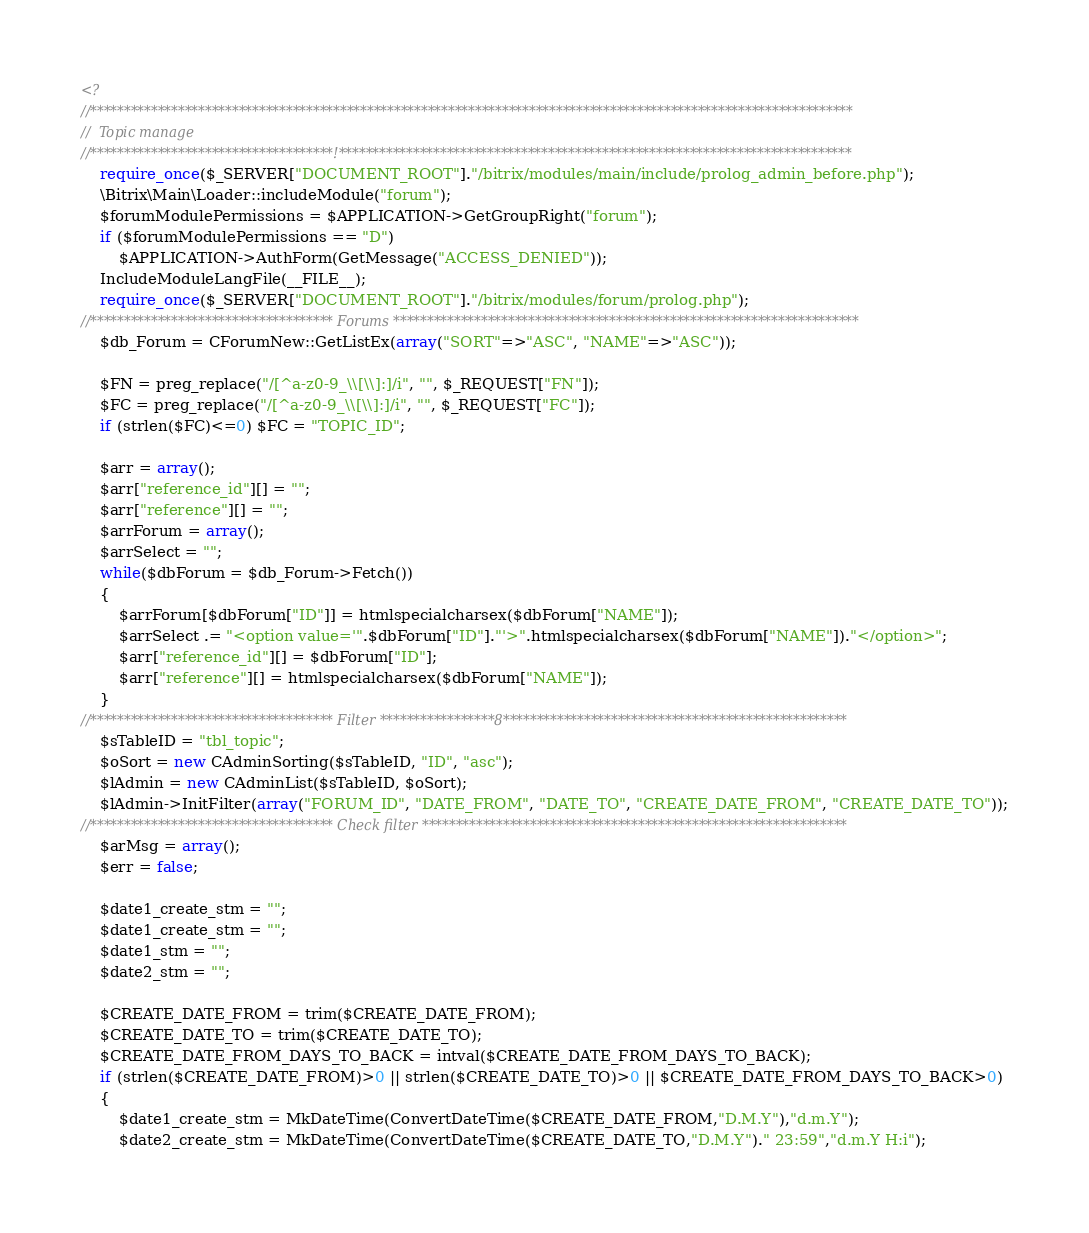Convert code to text. <code><loc_0><loc_0><loc_500><loc_500><_PHP_><?
//*****************************************************************************************************************
//	Topic manage
//************************************!****************************************************************************
	require_once($_SERVER["DOCUMENT_ROOT"]."/bitrix/modules/main/include/prolog_admin_before.php");
	\Bitrix\Main\Loader::includeModule("forum");
	$forumModulePermissions = $APPLICATION->GetGroupRight("forum");
	if ($forumModulePermissions == "D")
		$APPLICATION->AuthForm(GetMessage("ACCESS_DENIED"));
	IncludeModuleLangFile(__FILE__);
	require_once($_SERVER["DOCUMENT_ROOT"]."/bitrix/modules/forum/prolog.php");
//************************************ Forums *********************************************************************
	$db_Forum = CForumNew::GetListEx(array("SORT"=>"ASC", "NAME"=>"ASC"));

	$FN = preg_replace("/[^a-z0-9_\\[\\]:]/i", "", $_REQUEST["FN"]);
	$FC = preg_replace("/[^a-z0-9_\\[\\]:]/i", "", $_REQUEST["FC"]);
	if (strlen($FC)<=0) $FC = "TOPIC_ID";

	$arr = array();
	$arr["reference_id"][] = "";
	$arr["reference"][] = "";
	$arrForum = array();
	$arrSelect = "";
	while($dbForum = $db_Forum->Fetch())
	{
		$arrForum[$dbForum["ID"]] = htmlspecialcharsex($dbForum["NAME"]);
		$arrSelect .= "<option value='".$dbForum["ID"]."'>".htmlspecialcharsex($dbForum["NAME"])."</option>";
		$arr["reference_id"][] = $dbForum["ID"];
		$arr["reference"][] = htmlspecialcharsex($dbForum["NAME"]);
	}
//************************************ Filter *****************8***************************************************
	$sTableID = "tbl_topic";
	$oSort = new CAdminSorting($sTableID, "ID", "asc");
	$lAdmin = new CAdminList($sTableID, $oSort);
	$lAdmin->InitFilter(array("FORUM_ID", "DATE_FROM", "DATE_TO", "CREATE_DATE_FROM", "CREATE_DATE_TO"));
//************************************ Check filter ***************************************************************
	$arMsg = array();
	$err = false;

	$date1_create_stm = "";
	$date1_create_stm = "";
	$date1_stm = "";
	$date2_stm = "";

	$CREATE_DATE_FROM = trim($CREATE_DATE_FROM);
	$CREATE_DATE_TO = trim($CREATE_DATE_TO);
	$CREATE_DATE_FROM_DAYS_TO_BACK = intval($CREATE_DATE_FROM_DAYS_TO_BACK);
	if (strlen($CREATE_DATE_FROM)>0 || strlen($CREATE_DATE_TO)>0 || $CREATE_DATE_FROM_DAYS_TO_BACK>0)
	{
		$date1_create_stm = MkDateTime(ConvertDateTime($CREATE_DATE_FROM,"D.M.Y"),"d.m.Y");
		$date2_create_stm = MkDateTime(ConvertDateTime($CREATE_DATE_TO,"D.M.Y")." 23:59","d.m.Y H:i");
</code> 